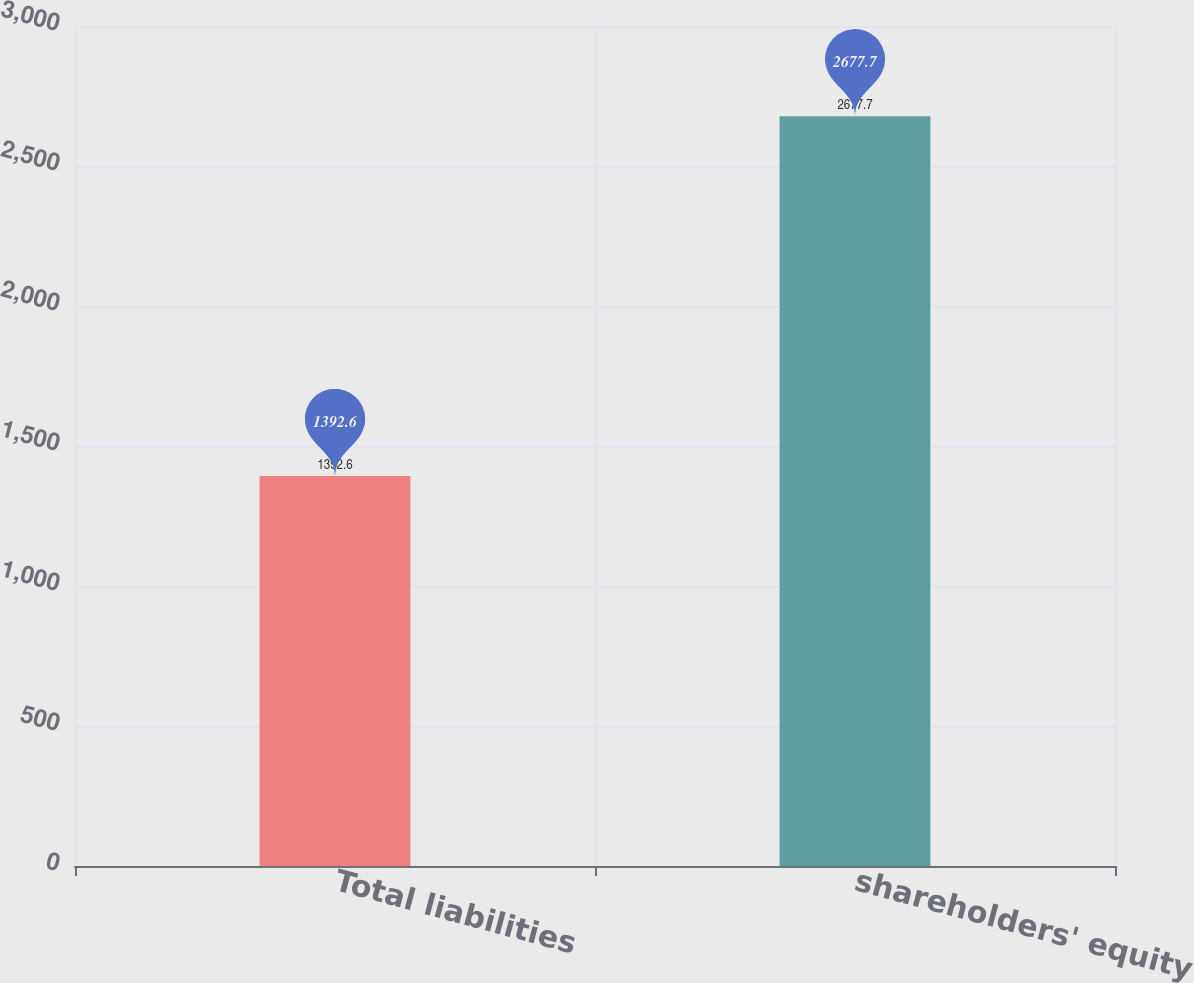<chart> <loc_0><loc_0><loc_500><loc_500><bar_chart><fcel>Total liabilities<fcel>shareholders' equity<nl><fcel>1392.6<fcel>2677.7<nl></chart> 